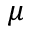<formula> <loc_0><loc_0><loc_500><loc_500>\mu</formula> 